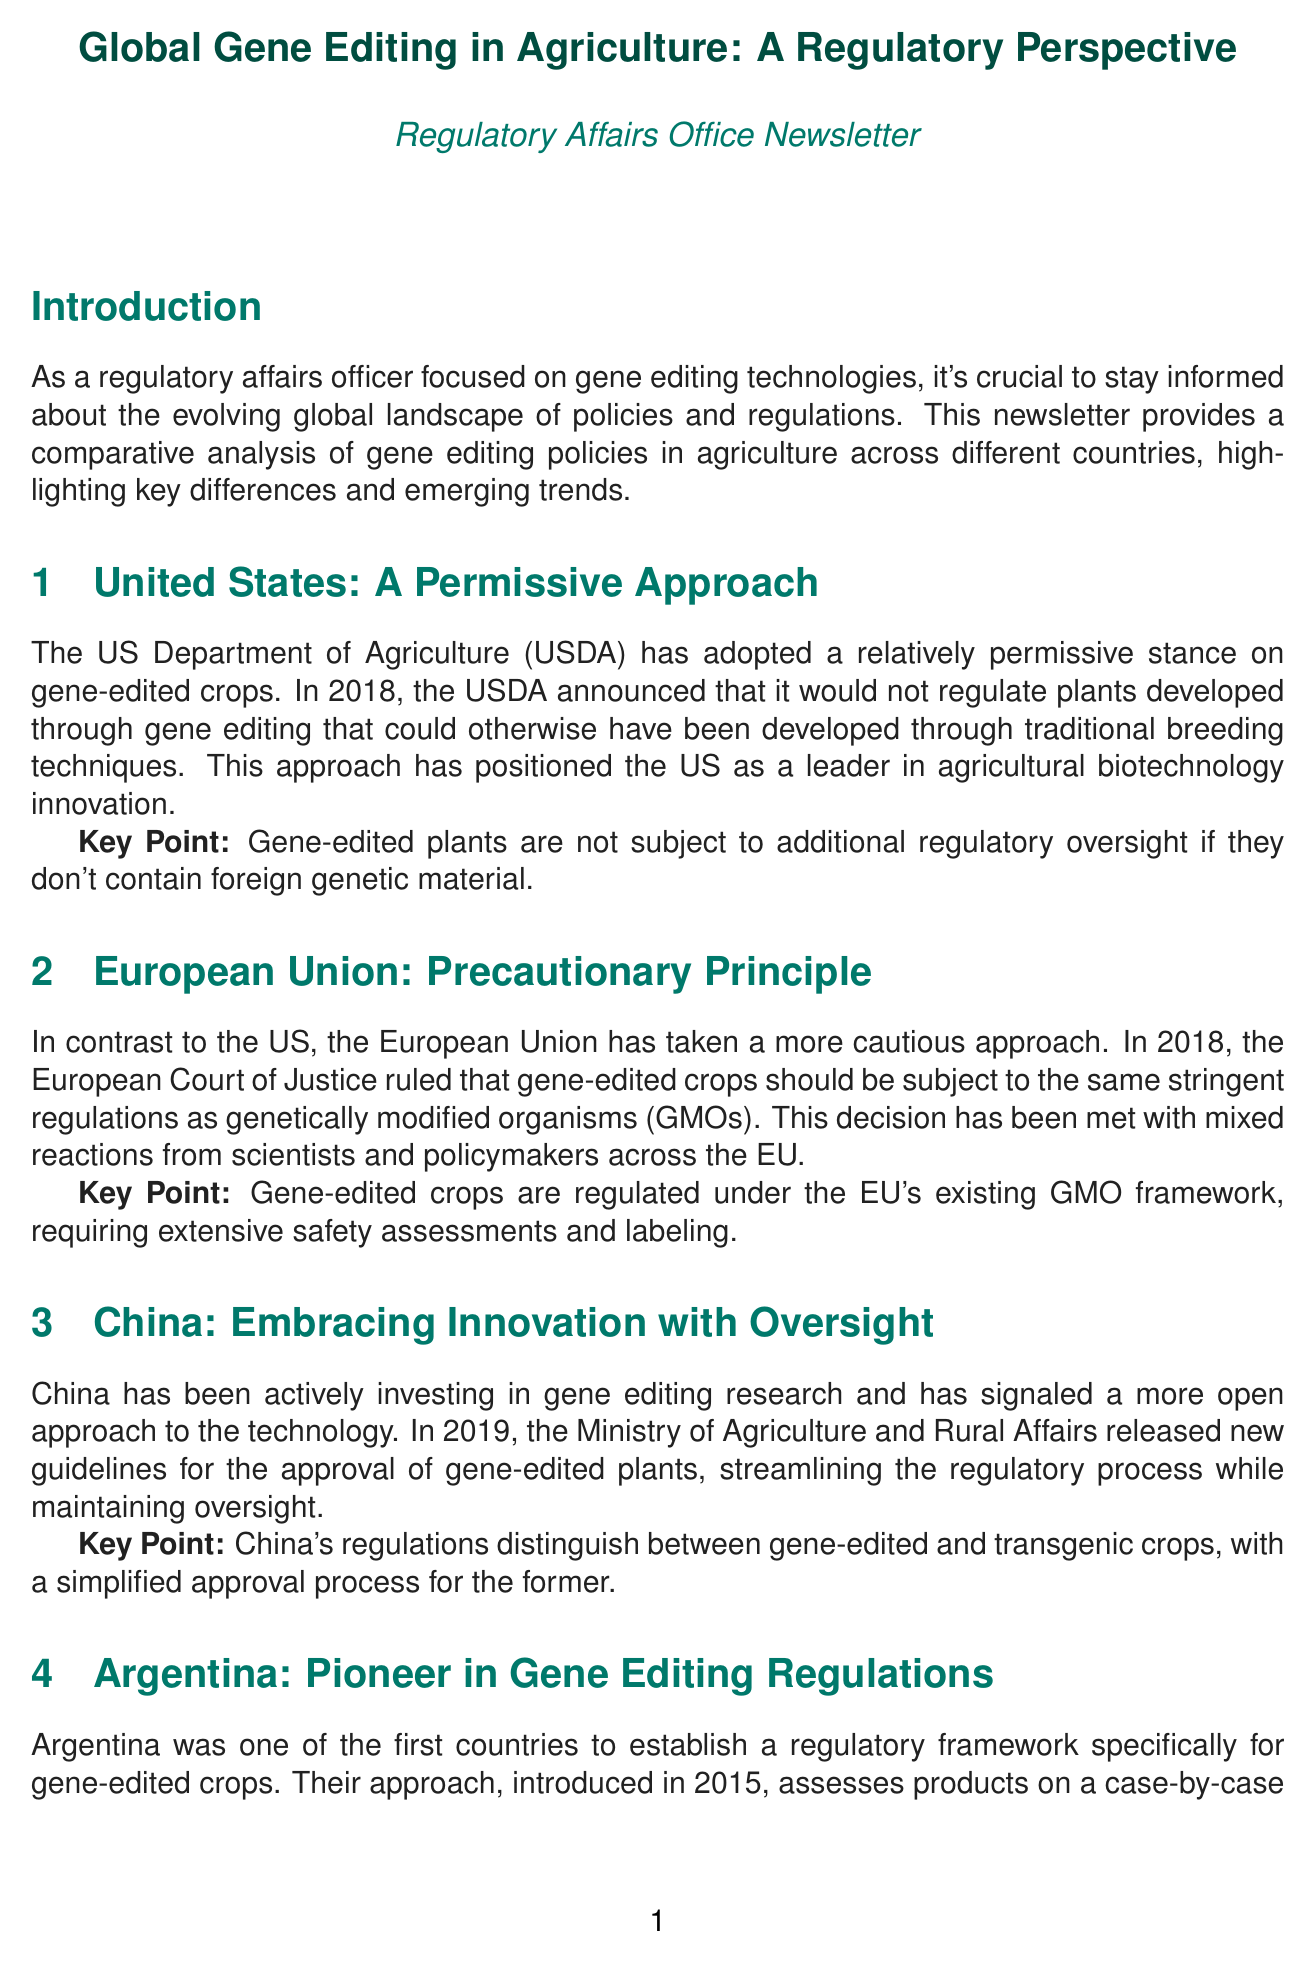what is the title of the newsletter? The title of the newsletter is presented at the beginning of the document.
Answer: Global Gene Editing in Agriculture: A Regulatory Perspective who has adopted a permissive stance on gene-edited crops? The document describes the US Department of Agriculture's stance regarding gene-edited crops.
Answer: US Department of Agriculture what year did the European Court of Justice rule on gene-edited crops? The document specifies the year when the ruling occurred regarding gene-edited crops in the EU.
Answer: 2018 which country was a pioneer in establishing regulations for gene-edited crops? The document mentions Argentina as one of the first countries to create a regulatory framework specifically for gene-edited crops.
Answer: Argentina what is the regulatory focus in the European Union? The document highlights the principle that underpins the EU's regulatory approach to gene-edited crops.
Answer: Precautionary Principle how are gene-edited crops regulated under the EU framework? The document notes how gene-edited crops are subjected to the EU's existing GMO regulations.
Answer: Extensive safety assessments and labeling what do the US and Argentina focus on in their regulatory approaches? The document compares regulatory focuses between different countries regarding gene editing.
Answer: End product which international organization is mentioned in the newsletter for promoting regulatory coherence? The document refers to an organization involved in regulatory harmonization efforts.
Answer: OECD what trend is emphasized alongside tailored regulations? The document discusses developing systems that differentiate among types of genetic modifications.
Answer: Tiered regulatory systems 